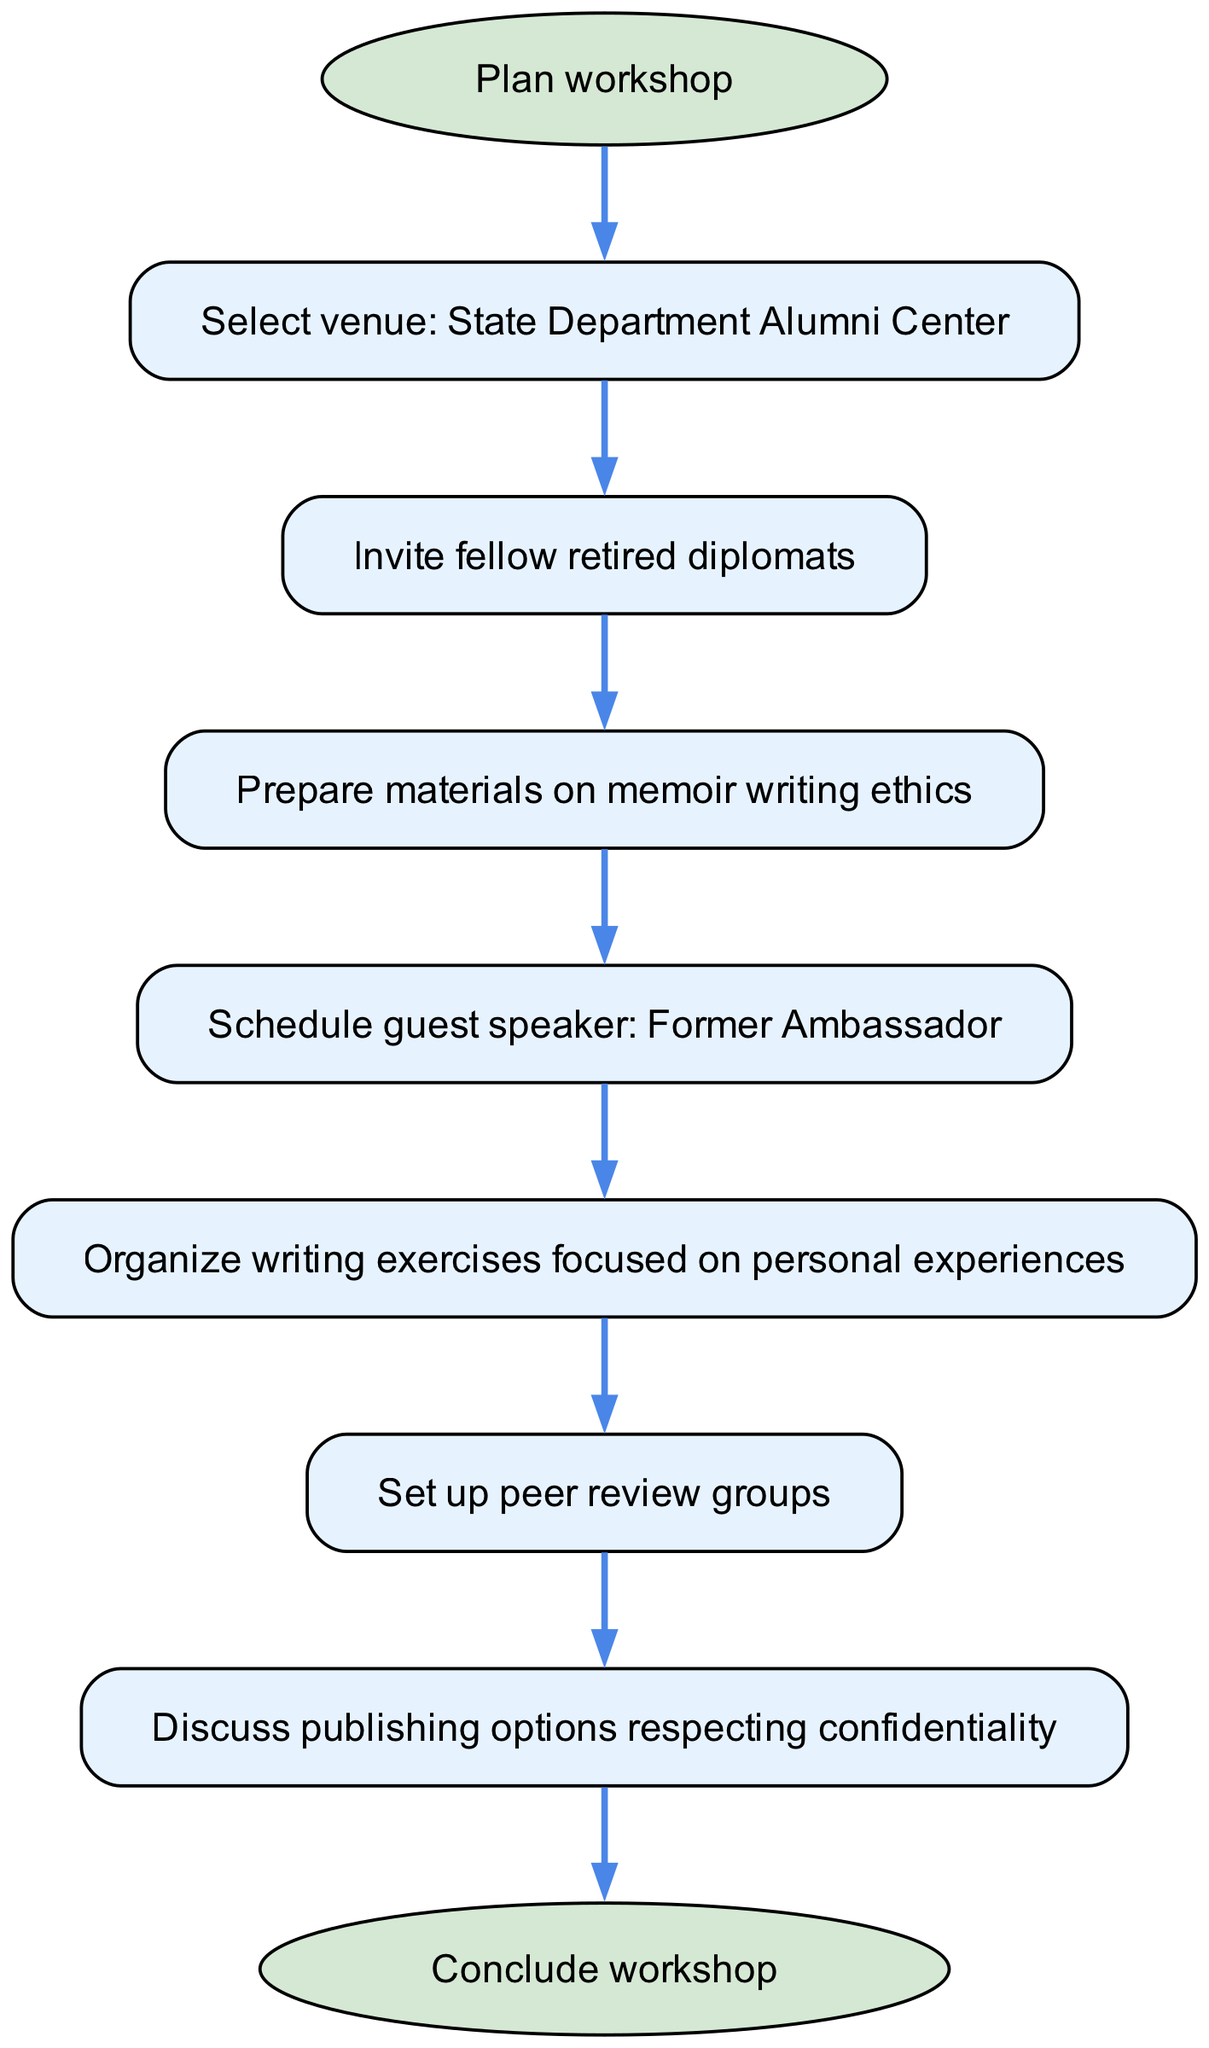What is the first step in the workshop organization? The diagram indicates that the first step, represented by the "start" node, is "Plan workshop". This is the initial action before moving forward with other steps.
Answer: Plan workshop How many steps are there in total? Counting the nodes from "Plan workshop" to "Conclude workshop", including all intermediate steps (1 to 7), there are a total of 8 steps represented in the diagram.
Answer: 8 Which step involves inviting fellow retirees? The diagram shows that "Invite fellow retired diplomats" is the second step, following the selection of the venue. It directly connects from the first step "Select venue: State Department Alumni Center".
Answer: Invite fellow retired diplomats What is the final step in the workshop process? According to the diagram, the final step is indicated by the "end" node, which states "Conclude workshop". This signifies the completion of all previous activities.
Answer: Conclude workshop Which step comes after preparing the materials? The diagram clearly shows that after "Prepare materials on memoir writing ethics," the next step is "Schedule guest speaker: Former Ambassador." This shows the flow of activities sequentially.
Answer: Schedule guest speaker: Former Ambassador What is the purpose of setting up peer review groups? The purpose is to facilitate feedback and discussion among participants about their writing. The diagram flow indicates this step follows organizing writing exercises and is essential for collaborative improvement.
Answer: Discuss publishing options respecting confidentiality How are guest speakers incorporated into the workshop? The diagram shows that scheduling a guest speaker ("Former Ambassador") is a step after preparing writing materials and before organizing writing exercises, indicating that guest speakers are integrated early on to provide insights during the workshop.
Answer: Schedule guest speaker: Former Ambassador Which node emphasizes confidentiality in publishing options? The node titled "Discuss publishing options respecting confidentiality" addresses confidentiality, indicating a focus on ethical considerations regarding publishing memoirs, which comes after peer reviews in the sequence.
Answer: Discuss publishing options respecting confidentiality 